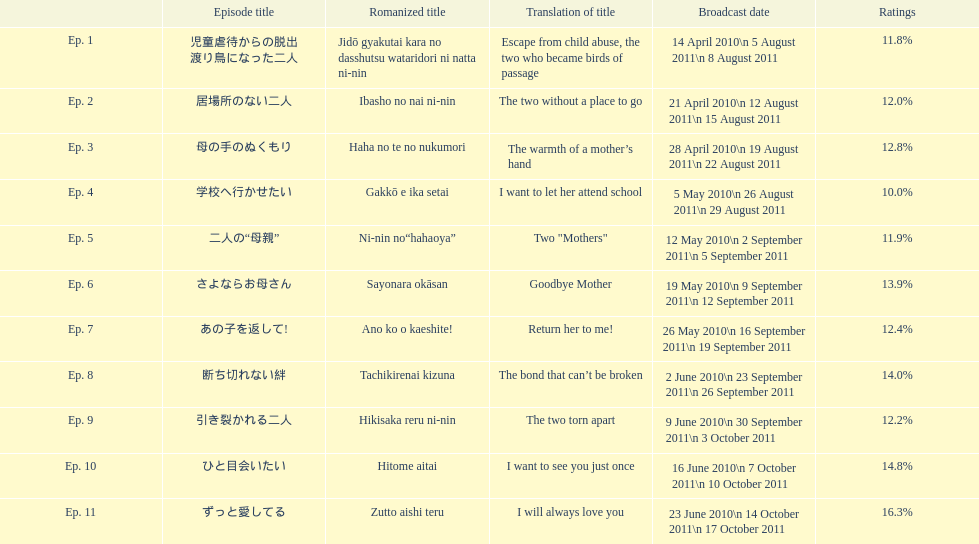How many episodes had a consecutive rating over 11%? 7. I'm looking to parse the entire table for insights. Could you assist me with that? {'header': ['', 'Episode title', 'Romanized title', 'Translation of title', 'Broadcast date', 'Ratings'], 'rows': [['Ep. 1', '児童虐待からの脱出 渡り鳥になった二人', 'Jidō gyakutai kara no dasshutsu wataridori ni natta ni-nin', 'Escape from child abuse, the two who became birds of passage', '14 April 2010\\n 5 August 2011\\n 8 August 2011', '11.8%'], ['Ep. 2', '居場所のない二人', 'Ibasho no nai ni-nin', 'The two without a place to go', '21 April 2010\\n 12 August 2011\\n 15 August 2011', '12.0%'], ['Ep. 3', '母の手のぬくもり', 'Haha no te no nukumori', 'The warmth of a mother’s hand', '28 April 2010\\n 19 August 2011\\n 22 August 2011', '12.8%'], ['Ep. 4', '学校へ行かせたい', 'Gakkō e ika setai', 'I want to let her attend school', '5 May 2010\\n 26 August 2011\\n 29 August 2011', '10.0%'], ['Ep. 5', '二人の“母親”', 'Ni-nin no“hahaoya”', 'Two "Mothers"', '12 May 2010\\n 2 September 2011\\n 5 September 2011', '11.9%'], ['Ep. 6', 'さよならお母さん', 'Sayonara okāsan', 'Goodbye Mother', '19 May 2010\\n 9 September 2011\\n 12 September 2011', '13.9%'], ['Ep. 7', 'あの子を返して!', 'Ano ko o kaeshite!', 'Return her to me!', '26 May 2010\\n 16 September 2011\\n 19 September 2011', '12.4%'], ['Ep. 8', '断ち切れない絆', 'Tachikirenai kizuna', 'The bond that can’t be broken', '2 June 2010\\n 23 September 2011\\n 26 September 2011', '14.0%'], ['Ep. 9', '引き裂かれる二人', 'Hikisaka reru ni-nin', 'The two torn apart', '9 June 2010\\n 30 September 2011\\n 3 October 2011', '12.2%'], ['Ep. 10', 'ひと目会いたい', 'Hitome aitai', 'I want to see you just once', '16 June 2010\\n 7 October 2011\\n 10 October 2011', '14.8%'], ['Ep. 11', 'ずっと愛してる', 'Zutto aishi teru', 'I will always love you', '23 June 2010\\n 14 October 2011\\n 17 October 2011', '16.3%']]} 